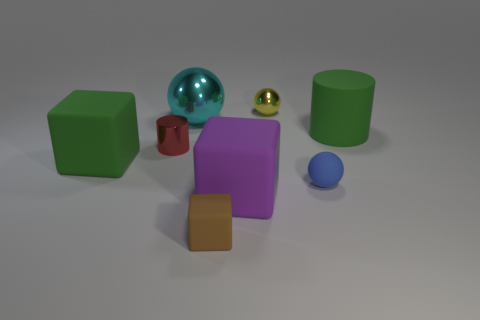Add 2 red cylinders. How many objects exist? 10 Subtract all spheres. How many objects are left? 5 Add 8 brown cubes. How many brown cubes are left? 9 Add 1 green blocks. How many green blocks exist? 2 Subtract 0 blue cubes. How many objects are left? 8 Subtract all big purple matte blocks. Subtract all purple objects. How many objects are left? 6 